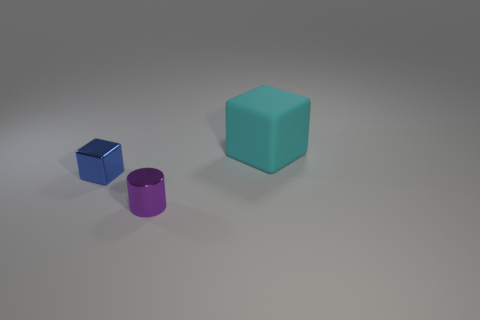Is there any other thing that has the same material as the cyan thing?
Your answer should be very brief. No. There is a object that is both on the left side of the matte thing and right of the metal cube; what material is it made of?
Offer a very short reply. Metal. Is the size of the blue metallic object the same as the cyan object?
Offer a very short reply. No. There is a object left of the tiny thing on the right side of the blue block; how big is it?
Provide a short and direct response. Small. What number of things are left of the purple cylinder and in front of the blue shiny block?
Ensure brevity in your answer.  0. There is a tiny metal thing on the right side of the cube that is left of the rubber block; is there a tiny purple shiny cylinder that is in front of it?
Offer a terse response. No. There is a blue object that is the same size as the purple metallic object; what shape is it?
Offer a very short reply. Cube. Is there another large block of the same color as the matte cube?
Provide a succinct answer. No. Is the shape of the cyan object the same as the purple object?
Provide a succinct answer. No. How many small objects are blue metal things or rubber blocks?
Offer a very short reply. 1. 